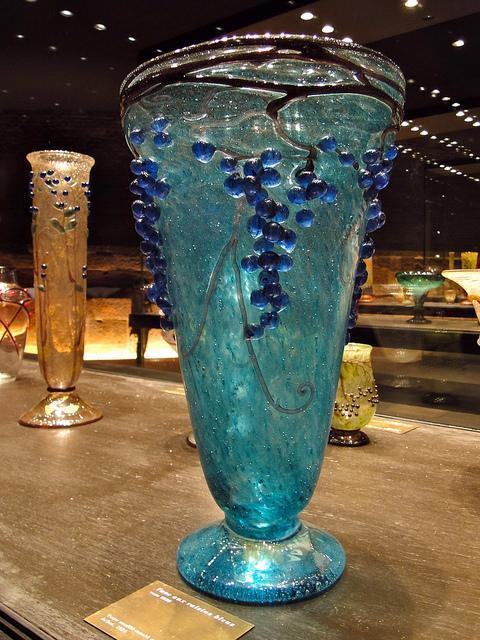How many vases are there?
Give a very brief answer. 3. How many cats are here?
Give a very brief answer. 0. 